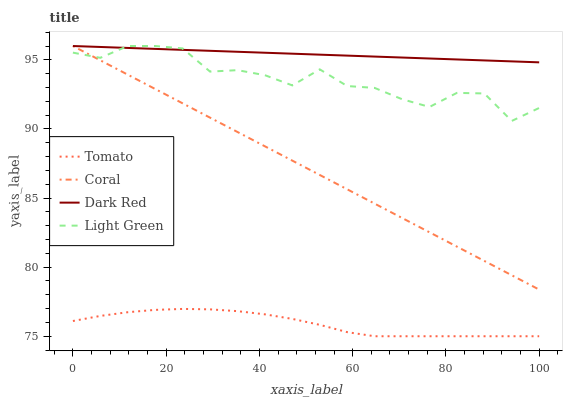Does Tomato have the minimum area under the curve?
Answer yes or no. Yes. Does Dark Red have the maximum area under the curve?
Answer yes or no. Yes. Does Coral have the minimum area under the curve?
Answer yes or no. No. Does Coral have the maximum area under the curve?
Answer yes or no. No. Is Dark Red the smoothest?
Answer yes or no. Yes. Is Light Green the roughest?
Answer yes or no. Yes. Is Coral the smoothest?
Answer yes or no. No. Is Coral the roughest?
Answer yes or no. No. Does Coral have the lowest value?
Answer yes or no. No. Does Light Green have the highest value?
Answer yes or no. Yes. Is Tomato less than Coral?
Answer yes or no. Yes. Is Dark Red greater than Tomato?
Answer yes or no. Yes. Does Coral intersect Light Green?
Answer yes or no. Yes. Is Coral less than Light Green?
Answer yes or no. No. Is Coral greater than Light Green?
Answer yes or no. No. Does Tomato intersect Coral?
Answer yes or no. No. 